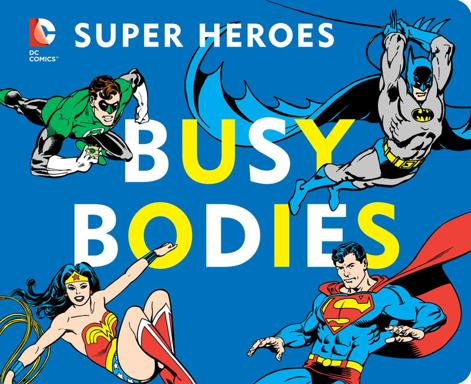Can you describe the appearance of the mousepad? The mousepad features a brightly colored backdrop dominated by blue, displaying classic images of Batman, Superman, and Wonder Woman in bold action poses. These characters are illustrated in a traditional comic book style, emphasizing their heroic qualities. 